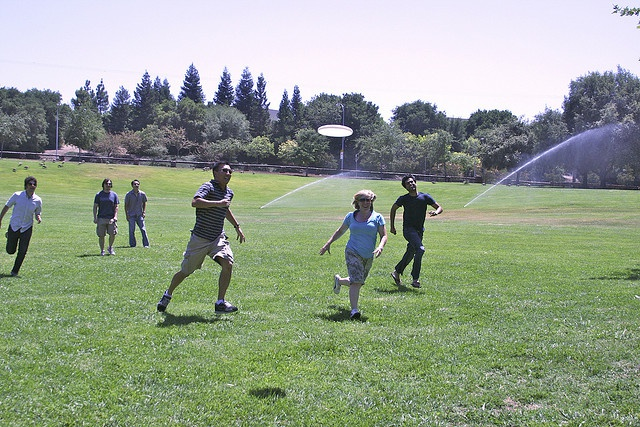Describe the objects in this image and their specific colors. I can see people in lavender, black, gray, and darkgreen tones, people in lavender, gray, blue, and black tones, people in lavender, black, gray, and olive tones, people in lavender, black, navy, gray, and darkgray tones, and people in lavender, gray, black, navy, and darkgray tones in this image. 